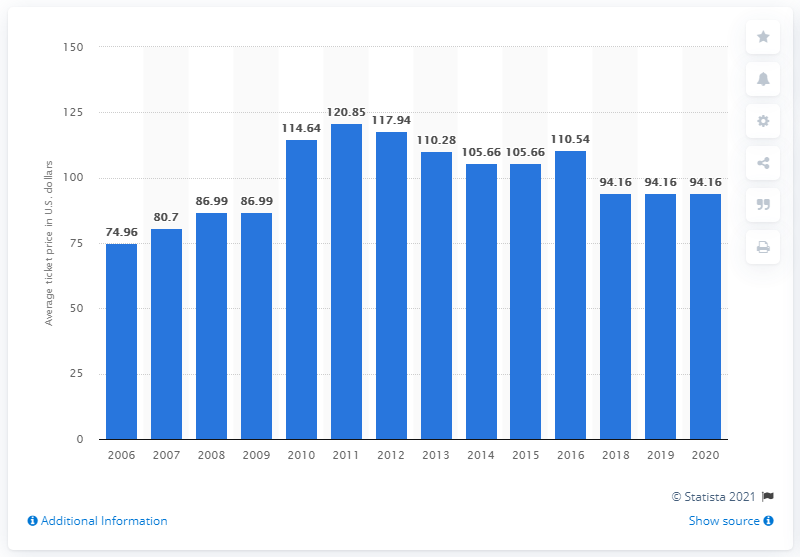Highlight a few significant elements in this photo. In 2020, the average ticket price for New York Jets games was $94.16. 